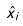Convert formula to latex. <formula><loc_0><loc_0><loc_500><loc_500>\hat { x } _ { i }</formula> 